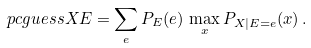<formula> <loc_0><loc_0><loc_500><loc_500>\ p c g u e s s { X } { E } = \sum _ { e } P _ { E } ( e ) \, \max _ { x } P _ { X | E = e } ( x ) \, .</formula> 